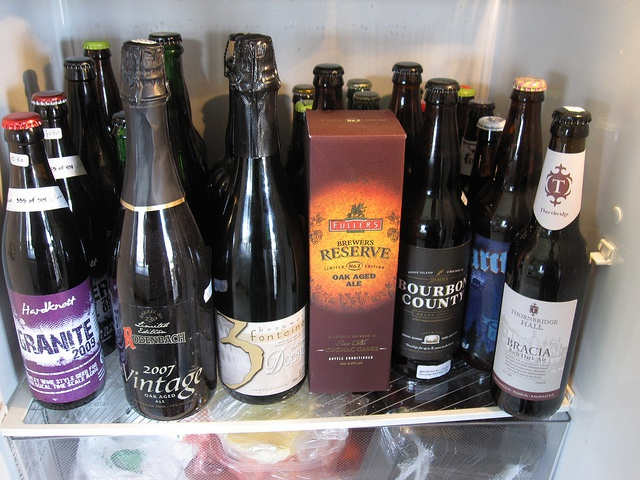Describe the objects in this image and their specific colors. I can see refrigerator in black, lightgray, darkgray, and gray tones, bottle in darkgray, black, gray, and white tones, bottle in darkgray, black, lightgray, and gray tones, bottle in darkgray, black, gray, and brown tones, and bottle in darkgray, black, lightgray, and gray tones in this image. 